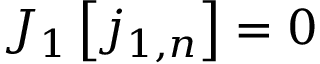Convert formula to latex. <formula><loc_0><loc_0><loc_500><loc_500>J _ { 1 } \left [ j _ { 1 , n } \right ] = 0</formula> 